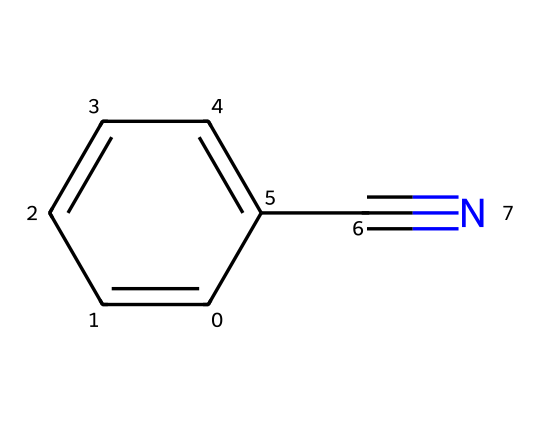What is the molecular formula of benzonitrile? To determine the molecular formula, we identify the elements present in the SMILES representation. The structure indicates 7 carbon (C) atoms from the aromatic ring and the carbon in the cyano group, 5 hydrogen (H) atoms from the aromatic ring, and 1 nitrogen (N) atom from the cyano group. Thus, the molecular formula is C7H5N.
Answer: C7H5N How many rings are present in the structure of benzonitrile? By analyzing the SMILES representation, we see the presence of the benzene ring (c1ccccc1) which indicates a closed ring structure. There are no other rings reported in the SMILES. Hence, there is only one ring present.
Answer: 1 What functional group is present in benzonitrile? The presence of the cyano group (C#N) indicates the functional group in this compound. In nitriles, the cyano group is characteristic, contributing to the chemical's reactivity and properties.
Answer: cyano group How many double bonds are in the structure of benzonitrile? Reviewing the structure, the presence of the aromatic ring usually includes alternating single and double bonds, but we notice a triple bond between the carbon and nitrogen in the cyano group (C#N). Although there are alternating double bonds in benzene, the inquiry is focused on distinct double or triple bonds. Thus, there are effectively 0 separate double bonds in the conventional sense within the cyclic part of the molecule since the cyano group is counted as a triple bond.
Answer: 0 What type of chemical reaction might benzonitrile undergo due to its structure? Given its structure, benzonitrile can undergo nucleophilic addition reactions due to the electrophilic nature of the carbon in the cyano group. The presence of the aromatic ring can also enable electrophilic substitution reactions on the benzene portion. The reasoning involves identifying the reactive sites in the structure: the carbon in the cyano group (C#N) attracts nucleophiles, while the benzene ring can attract electrophiles.
Answer: nucleophilic addition 